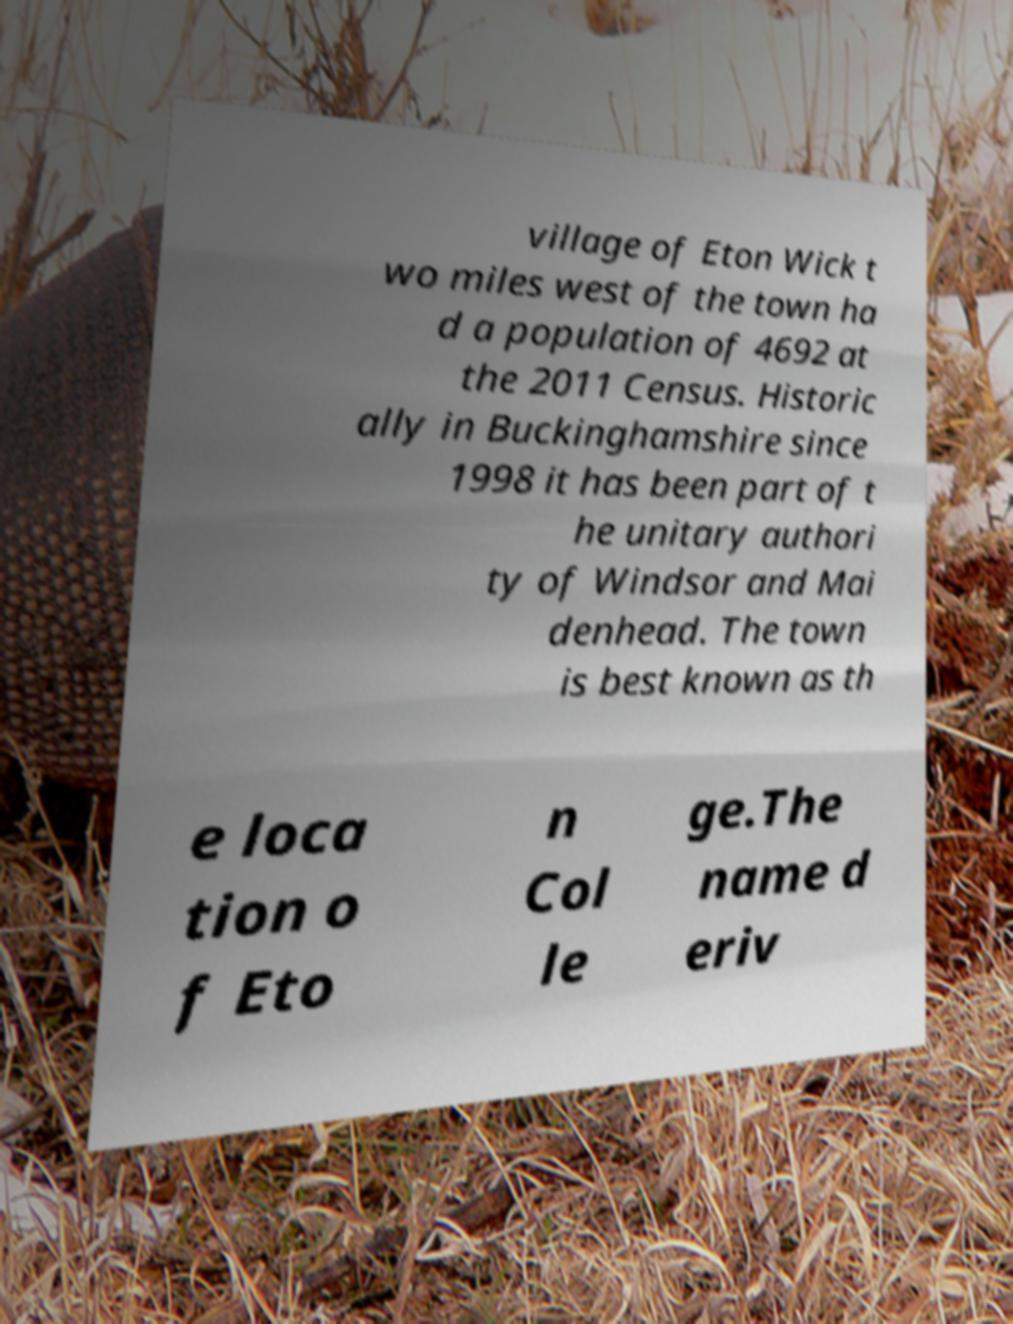Please identify and transcribe the text found in this image. village of Eton Wick t wo miles west of the town ha d a population of 4692 at the 2011 Census. Historic ally in Buckinghamshire since 1998 it has been part of t he unitary authori ty of Windsor and Mai denhead. The town is best known as th e loca tion o f Eto n Col le ge.The name d eriv 